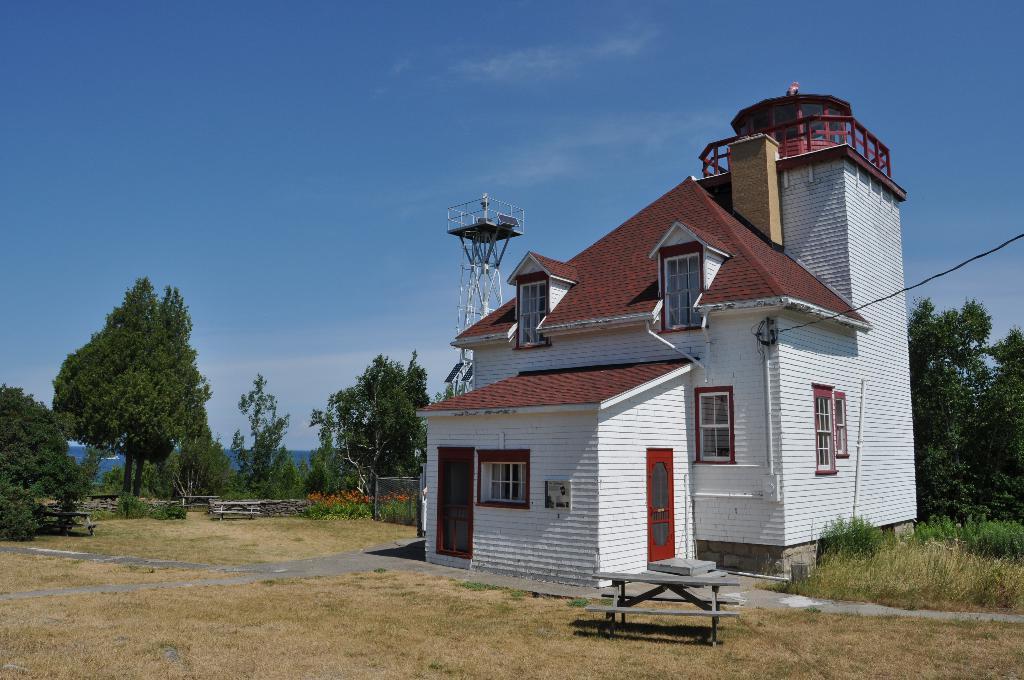Can you describe this image briefly? In this image I can see the building which is in white and dark brown color. In-front of the building I can see the bench and the ground. In the back there are many trees and the blue sky. 